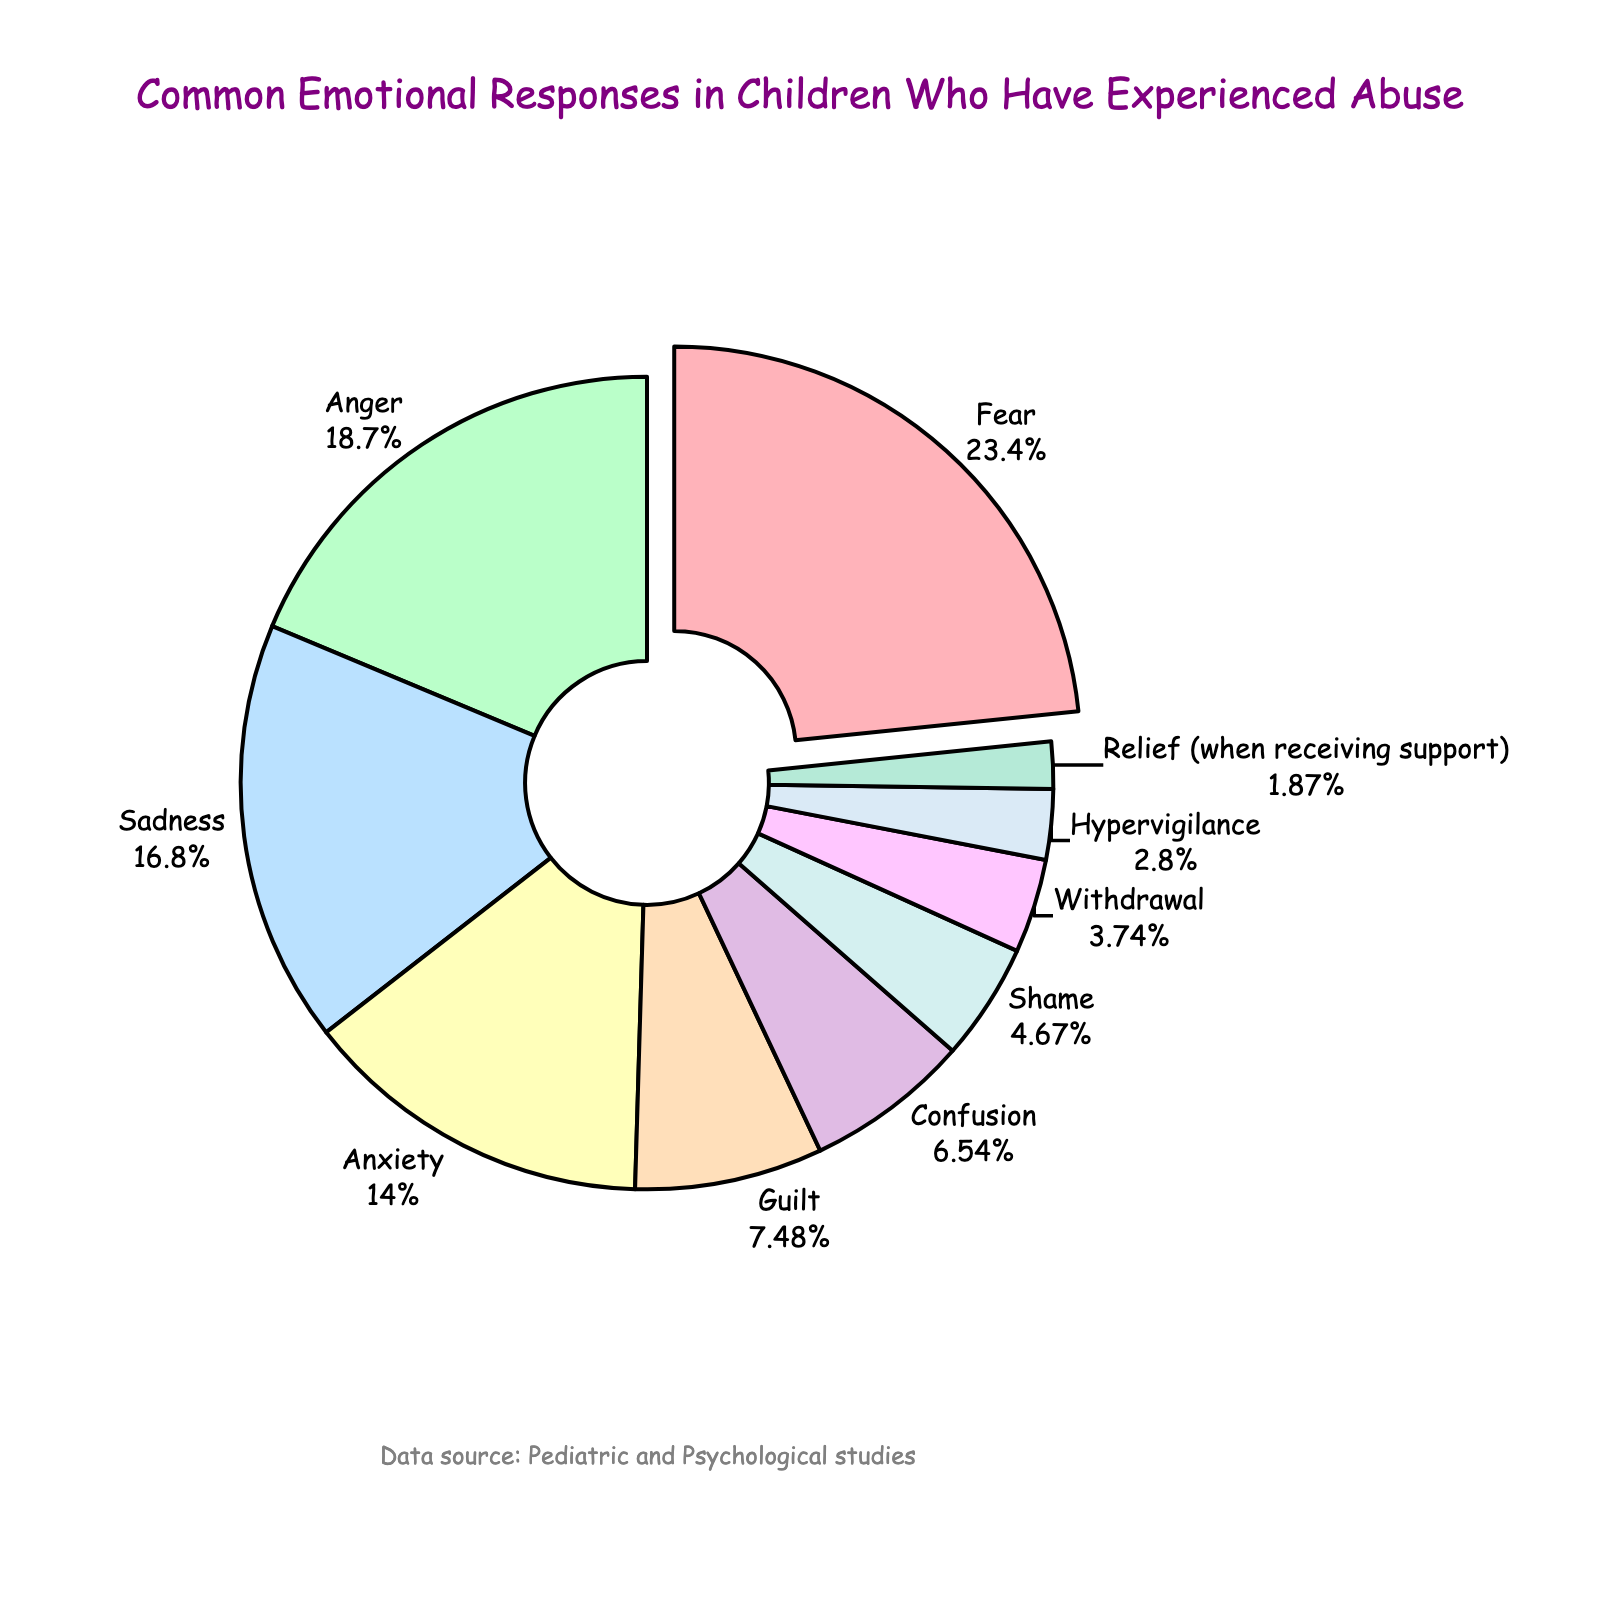What's the most common emotional response shown in the figure? The largest slice of the pie chart represents the most common emotional response. The slice labeled "Fear" is the largest, making it the most common emotional response.
Answer: Fear What is the difference in percentage between Anger and Relief (when receiving support)? The Anger slice shows 20% and the Relief (when receiving support) slice shows 2%. Subtract 2 from 20 to find the difference. 20 - 2 = 18.
Answer: 18% How many emotional responses make up less than 10% of the distribution each? Look for slices that are smaller than 10%. The responses are Guilt (8%), Confusion (7%), Shame (5%), Withdrawal (4%), Hypervigilance (3%), and Relief (2%). Count these responses: 6 emotional responses.
Answer: 6 Are there more children who feel Anger or Sadness? Compare the sizes of the Anger slice (20%) and the Sadness slice (18%). Anger has a higher percentage than Sadness.
Answer: Anger What percentage of children have a combination of Anxiety and Guilt as their primary emotional responses? Add the percentages for Anxiety (15%) and Guilt (8%). 15 + 8 = 23.
Answer: 23% Which emotional response has the second smallest percentage, and what is it? Find the second smallest slice in the pie chart. The smallest is Relief (2%), the second smallest is Hypervigilance (3%).
Answer: Hypervigilance, 3% Is Shame more common than Withdrawal? Compare the slice labeled Shame (5%) with the slice labeled Withdrawal (4%). Shame has a higher percentage than Withdrawal.
Answer: Yes What is the sum of the percentages for Fear, Anger, and Sadness? Add the percentages for Fear (25%), Anger (20%), and Sadness (18%). 25 + 20 + 18 = 63.
Answer: 63% How many emotional responses are represented with a percentage of 5% or higher? Identify slices with percentages of 5% or more: Fear (25%), Anger (20%), Sadness (18%), Anxiety (15%), Guilt (8%), Confusion (7%), and Shame (5%). Count these responses: 7.
Answer: 7 Which color represents the emotion with the highest percentage, and which emotion is it? The largest slice is labeled Fear and has a pinkish color.
Answer: Pink (for Fear) 